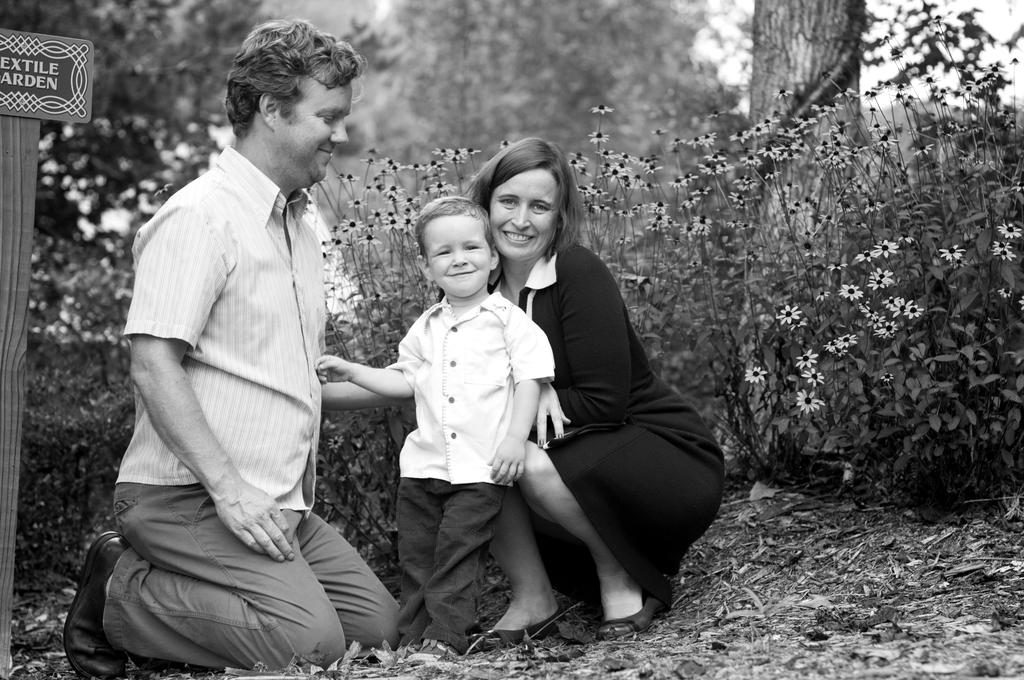How many people are in the image? There are three persons in the image. What other elements can be seen in the image besides the people? There are plants, flowers, and the trunk of a tree visible in the image. Can you describe the board and pole on the left side of the image? There is a board attached to a pole on the left side of the image. What type of machine is being used by the persons in the image? There is no machine visible in the image; the persons are not using any tools or devices. 